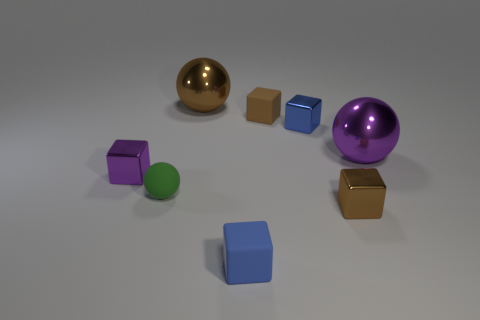Add 1 rubber balls. How many objects exist? 9 Subtract all metal balls. How many balls are left? 1 Subtract all spheres. How many objects are left? 5 Subtract 5 blocks. How many blocks are left? 0 Subtract all gray spheres. Subtract all gray blocks. How many spheres are left? 3 Subtract all brown blocks. How many brown balls are left? 1 Subtract all purple shiny spheres. Subtract all small blue things. How many objects are left? 5 Add 1 tiny matte cubes. How many tiny matte cubes are left? 3 Add 6 small blue matte things. How many small blue matte things exist? 7 Subtract all green balls. How many balls are left? 2 